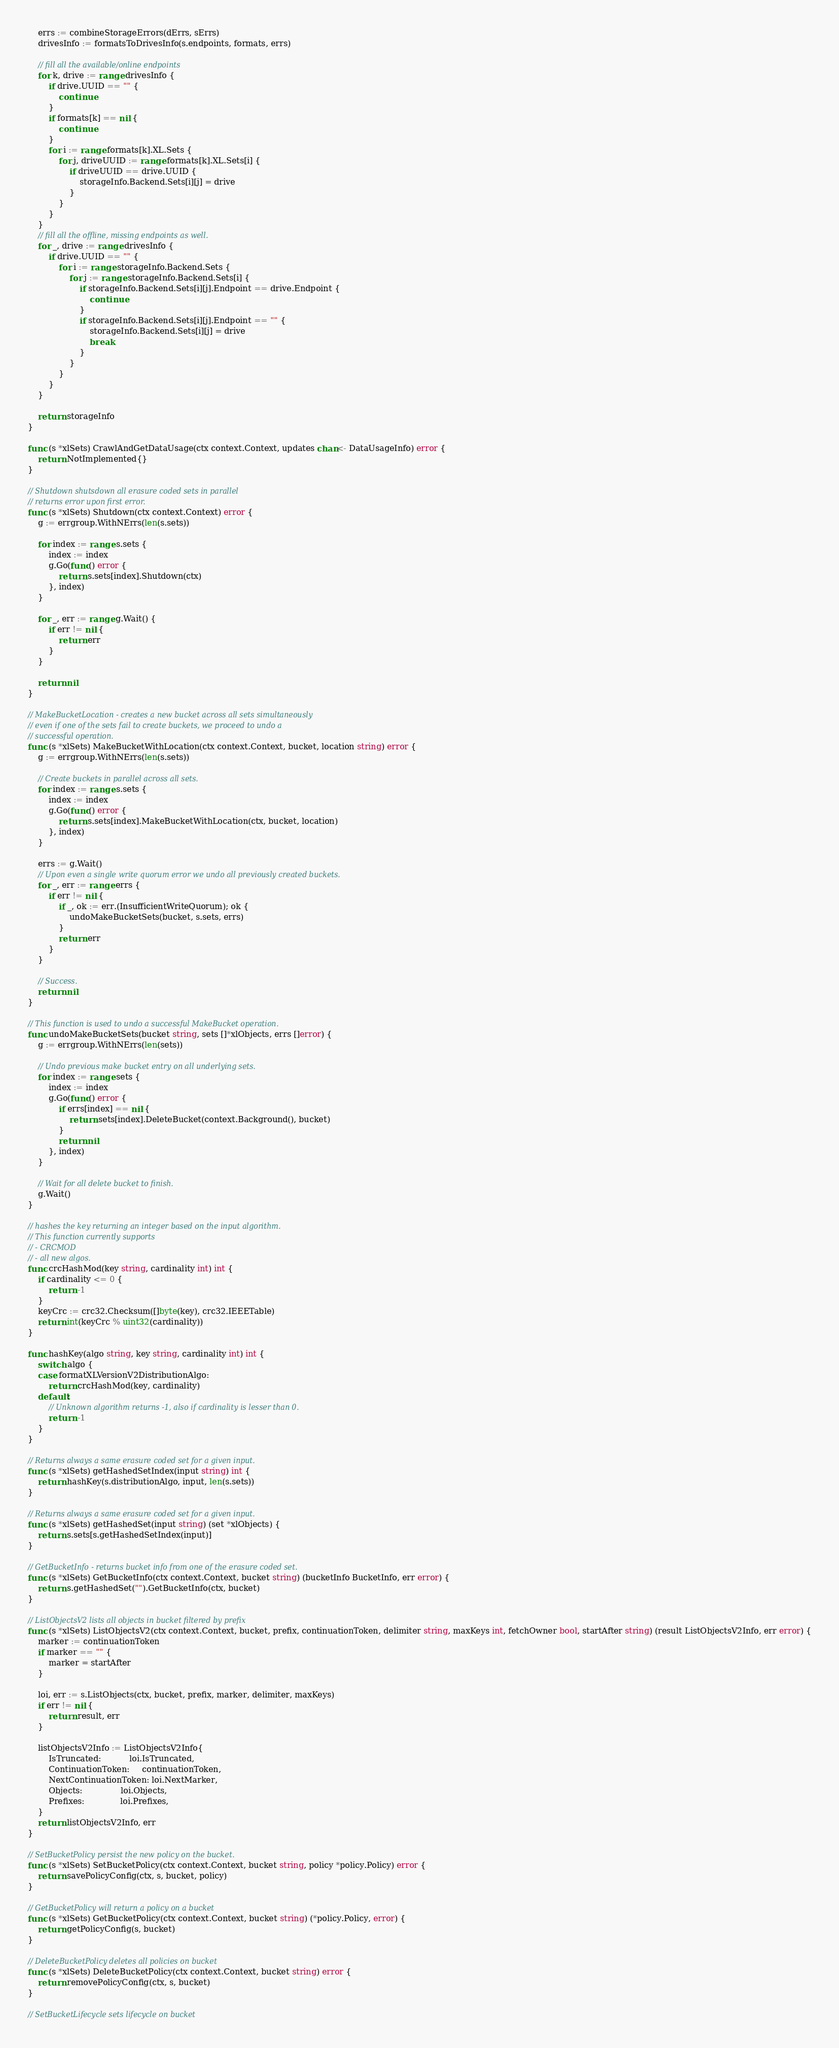Convert code to text. <code><loc_0><loc_0><loc_500><loc_500><_Go_>
	errs := combineStorageErrors(dErrs, sErrs)
	drivesInfo := formatsToDrivesInfo(s.endpoints, formats, errs)

	// fill all the available/online endpoints
	for k, drive := range drivesInfo {
		if drive.UUID == "" {
			continue
		}
		if formats[k] == nil {
			continue
		}
		for i := range formats[k].XL.Sets {
			for j, driveUUID := range formats[k].XL.Sets[i] {
				if driveUUID == drive.UUID {
					storageInfo.Backend.Sets[i][j] = drive
				}
			}
		}
	}
	// fill all the offline, missing endpoints as well.
	for _, drive := range drivesInfo {
		if drive.UUID == "" {
			for i := range storageInfo.Backend.Sets {
				for j := range storageInfo.Backend.Sets[i] {
					if storageInfo.Backend.Sets[i][j].Endpoint == drive.Endpoint {
						continue
					}
					if storageInfo.Backend.Sets[i][j].Endpoint == "" {
						storageInfo.Backend.Sets[i][j] = drive
						break
					}
				}
			}
		}
	}

	return storageInfo
}

func (s *xlSets) CrawlAndGetDataUsage(ctx context.Context, updates chan<- DataUsageInfo) error {
	return NotImplemented{}
}

// Shutdown shutsdown all erasure coded sets in parallel
// returns error upon first error.
func (s *xlSets) Shutdown(ctx context.Context) error {
	g := errgroup.WithNErrs(len(s.sets))

	for index := range s.sets {
		index := index
		g.Go(func() error {
			return s.sets[index].Shutdown(ctx)
		}, index)
	}

	for _, err := range g.Wait() {
		if err != nil {
			return err
		}
	}

	return nil
}

// MakeBucketLocation - creates a new bucket across all sets simultaneously
// even if one of the sets fail to create buckets, we proceed to undo a
// successful operation.
func (s *xlSets) MakeBucketWithLocation(ctx context.Context, bucket, location string) error {
	g := errgroup.WithNErrs(len(s.sets))

	// Create buckets in parallel across all sets.
	for index := range s.sets {
		index := index
		g.Go(func() error {
			return s.sets[index].MakeBucketWithLocation(ctx, bucket, location)
		}, index)
	}

	errs := g.Wait()
	// Upon even a single write quorum error we undo all previously created buckets.
	for _, err := range errs {
		if err != nil {
			if _, ok := err.(InsufficientWriteQuorum); ok {
				undoMakeBucketSets(bucket, s.sets, errs)
			}
			return err
		}
	}

	// Success.
	return nil
}

// This function is used to undo a successful MakeBucket operation.
func undoMakeBucketSets(bucket string, sets []*xlObjects, errs []error) {
	g := errgroup.WithNErrs(len(sets))

	// Undo previous make bucket entry on all underlying sets.
	for index := range sets {
		index := index
		g.Go(func() error {
			if errs[index] == nil {
				return sets[index].DeleteBucket(context.Background(), bucket)
			}
			return nil
		}, index)
	}

	// Wait for all delete bucket to finish.
	g.Wait()
}

// hashes the key returning an integer based on the input algorithm.
// This function currently supports
// - CRCMOD
// - all new algos.
func crcHashMod(key string, cardinality int) int {
	if cardinality <= 0 {
		return -1
	}
	keyCrc := crc32.Checksum([]byte(key), crc32.IEEETable)
	return int(keyCrc % uint32(cardinality))
}

func hashKey(algo string, key string, cardinality int) int {
	switch algo {
	case formatXLVersionV2DistributionAlgo:
		return crcHashMod(key, cardinality)
	default:
		// Unknown algorithm returns -1, also if cardinality is lesser than 0.
		return -1
	}
}

// Returns always a same erasure coded set for a given input.
func (s *xlSets) getHashedSetIndex(input string) int {
	return hashKey(s.distributionAlgo, input, len(s.sets))
}

// Returns always a same erasure coded set for a given input.
func (s *xlSets) getHashedSet(input string) (set *xlObjects) {
	return s.sets[s.getHashedSetIndex(input)]
}

// GetBucketInfo - returns bucket info from one of the erasure coded set.
func (s *xlSets) GetBucketInfo(ctx context.Context, bucket string) (bucketInfo BucketInfo, err error) {
	return s.getHashedSet("").GetBucketInfo(ctx, bucket)
}

// ListObjectsV2 lists all objects in bucket filtered by prefix
func (s *xlSets) ListObjectsV2(ctx context.Context, bucket, prefix, continuationToken, delimiter string, maxKeys int, fetchOwner bool, startAfter string) (result ListObjectsV2Info, err error) {
	marker := continuationToken
	if marker == "" {
		marker = startAfter
	}

	loi, err := s.ListObjects(ctx, bucket, prefix, marker, delimiter, maxKeys)
	if err != nil {
		return result, err
	}

	listObjectsV2Info := ListObjectsV2Info{
		IsTruncated:           loi.IsTruncated,
		ContinuationToken:     continuationToken,
		NextContinuationToken: loi.NextMarker,
		Objects:               loi.Objects,
		Prefixes:              loi.Prefixes,
	}
	return listObjectsV2Info, err
}

// SetBucketPolicy persist the new policy on the bucket.
func (s *xlSets) SetBucketPolicy(ctx context.Context, bucket string, policy *policy.Policy) error {
	return savePolicyConfig(ctx, s, bucket, policy)
}

// GetBucketPolicy will return a policy on a bucket
func (s *xlSets) GetBucketPolicy(ctx context.Context, bucket string) (*policy.Policy, error) {
	return getPolicyConfig(s, bucket)
}

// DeleteBucketPolicy deletes all policies on bucket
func (s *xlSets) DeleteBucketPolicy(ctx context.Context, bucket string) error {
	return removePolicyConfig(ctx, s, bucket)
}

// SetBucketLifecycle sets lifecycle on bucket</code> 